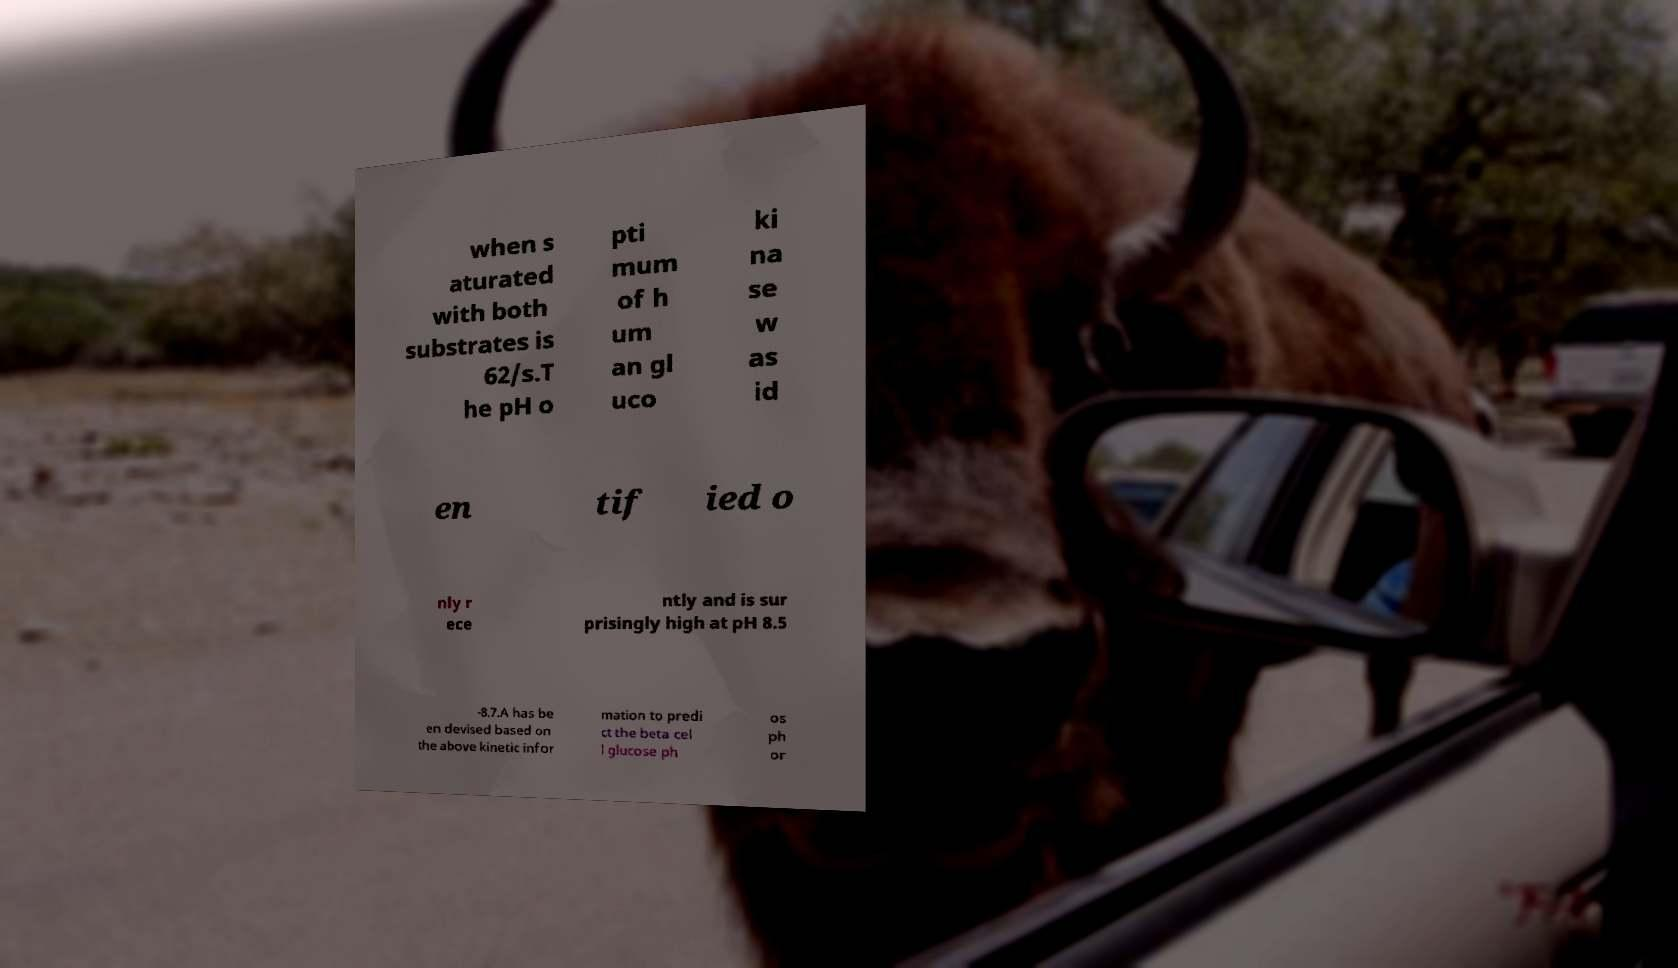What messages or text are displayed in this image? I need them in a readable, typed format. when s aturated with both substrates is 62/s.T he pH o pti mum of h um an gl uco ki na se w as id en tif ied o nly r ece ntly and is sur prisingly high at pH 8.5 -8.7.A has be en devised based on the above kinetic infor mation to predi ct the beta cel l glucose ph os ph or 